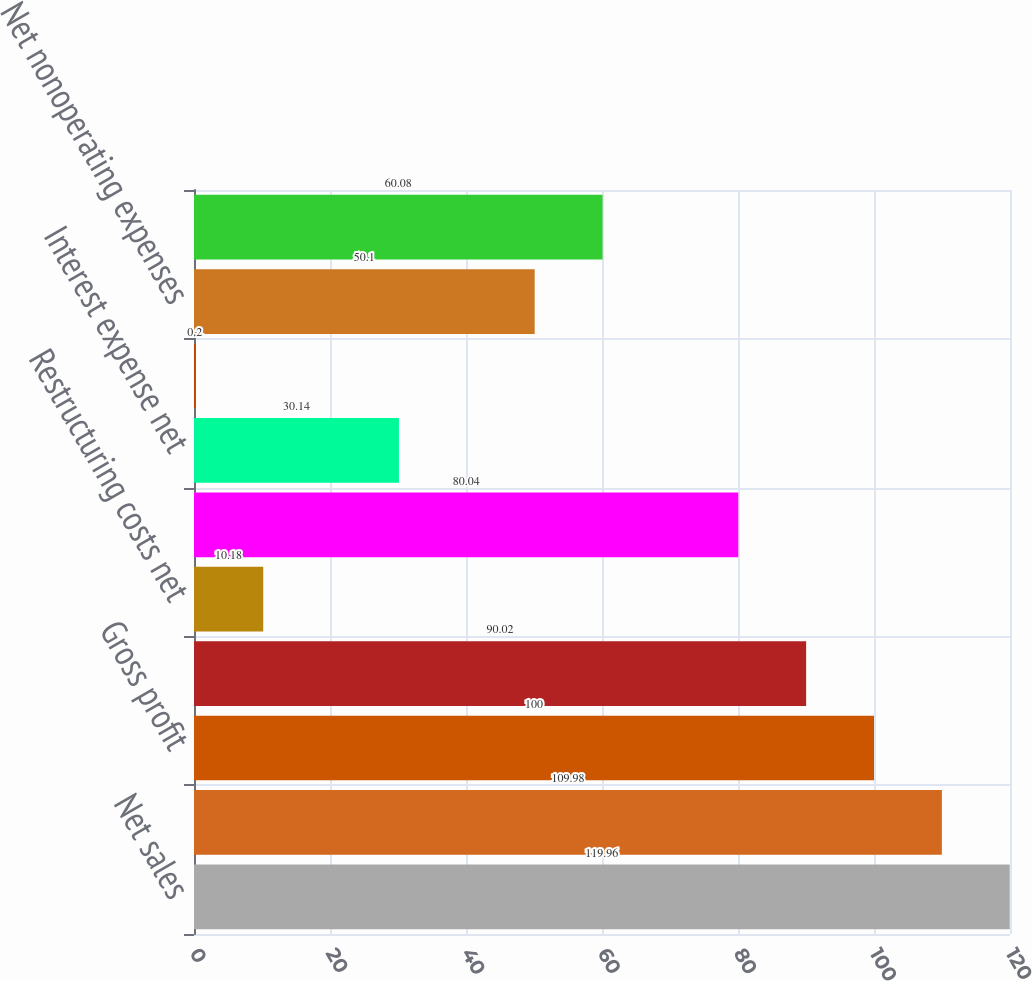<chart> <loc_0><loc_0><loc_500><loc_500><bar_chart><fcel>Net sales<fcel>Cost of products sold<fcel>Gross profit<fcel>Selling general and<fcel>Restructuring costs net<fcel>Operating income<fcel>Interest expense net<fcel>Other (income) expense net<fcel>Net nonoperating expenses<fcel>Income before income taxes<nl><fcel>119.96<fcel>109.98<fcel>100<fcel>90.02<fcel>10.18<fcel>80.04<fcel>30.14<fcel>0.2<fcel>50.1<fcel>60.08<nl></chart> 